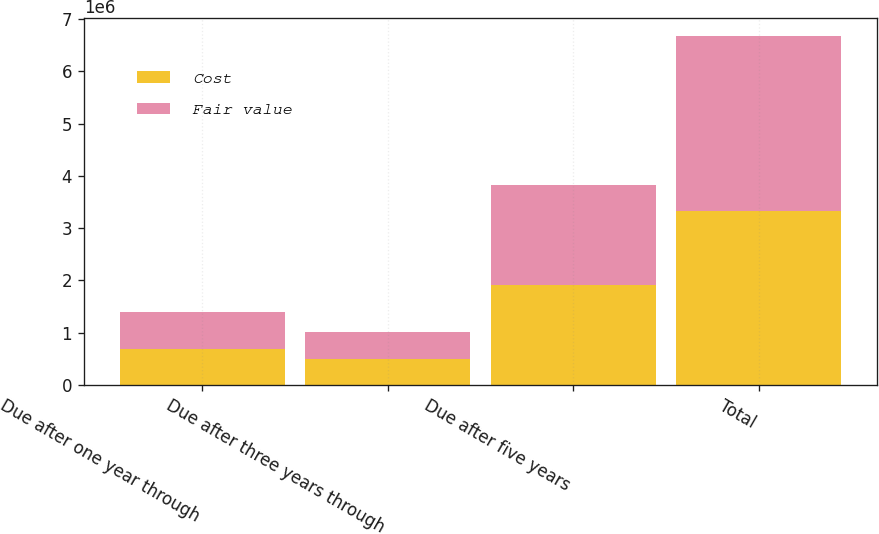<chart> <loc_0><loc_0><loc_500><loc_500><stacked_bar_chart><ecel><fcel>Due after one year through<fcel>Due after three years through<fcel>Due after five years<fcel>Total<nl><fcel>Cost<fcel>689772<fcel>501345<fcel>1.90669e+06<fcel>3.32875e+06<nl><fcel>Fair value<fcel>698967<fcel>509247<fcel>1.91353e+06<fcel>3.35346e+06<nl></chart> 